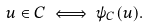<formula> <loc_0><loc_0><loc_500><loc_500>u \in C \iff \psi _ { C } ( u ) .</formula> 